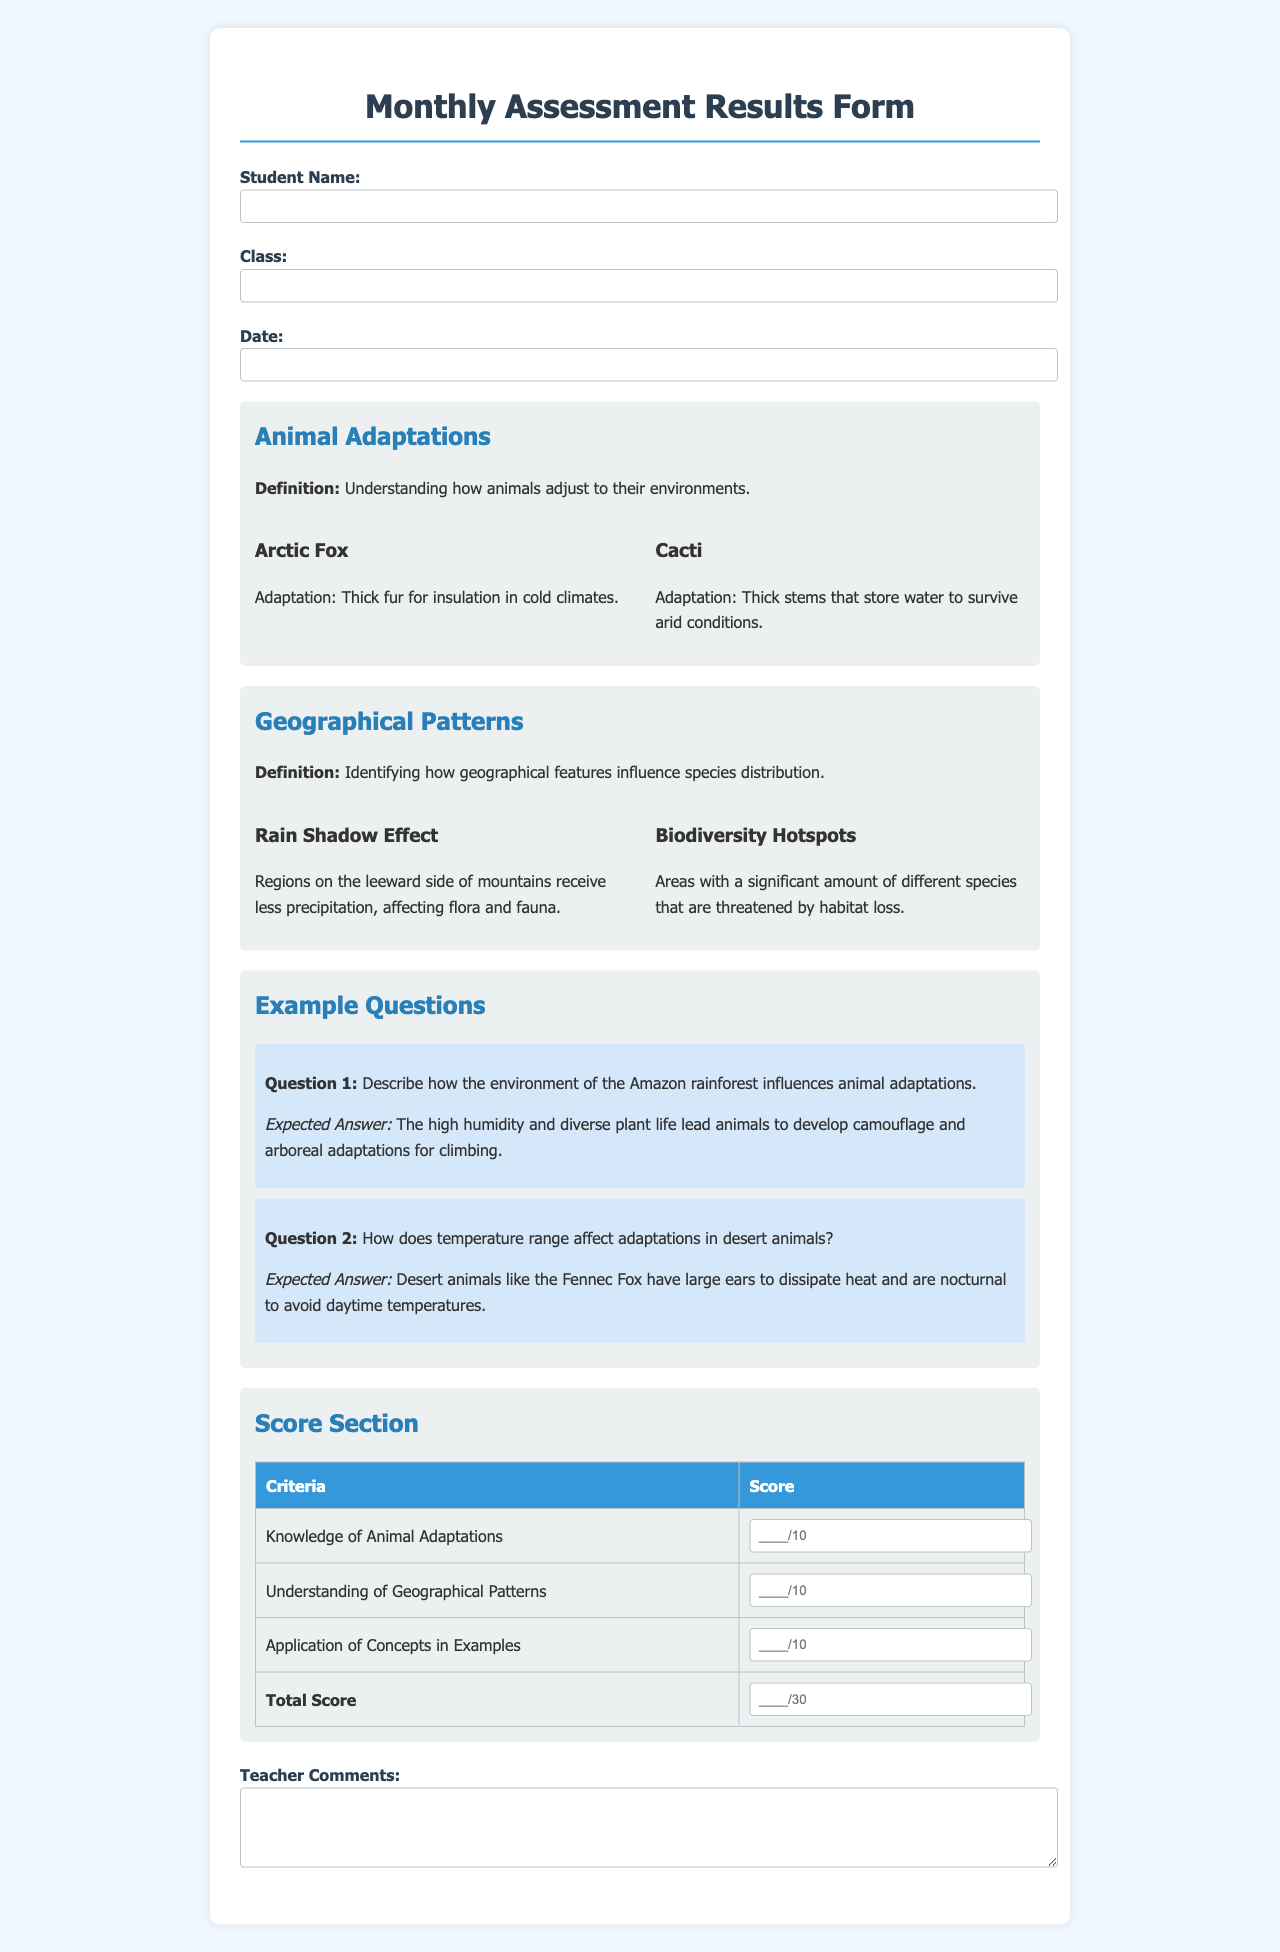What is the title of the document? The title is prominently displayed at the top of the document.
Answer: Monthly Assessment Results Form What species is mentioned as an example of adaptation in cold climates? The document provides specific examples of species with adaptations.
Answer: Arctic Fox How many points is the total score out of? The table clearly states the total points possible.
Answer: 30 What is one key concept related to geographical patterns? The document highlights multiple key concepts under geographical patterns.
Answer: Rain Shadow Effect What adaptation is noted for cacti? The document includes specific adaptations for different species.
Answer: Thick stems that store water What is the expected answer for Question 1? The expected answer is explicitly stated below the question in the document.
Answer: The high humidity and diverse plant life lead animals to develop camouflage and arboreal adaptations for climbing How many criteria are listed in the score section? The score section lists criteria for scoring in assessments.
Answer: 3 What is mentioned as a reason for the geographic patterns? The document provides definitions related to how features influence species.
Answer: Geographical features influence species distribution 